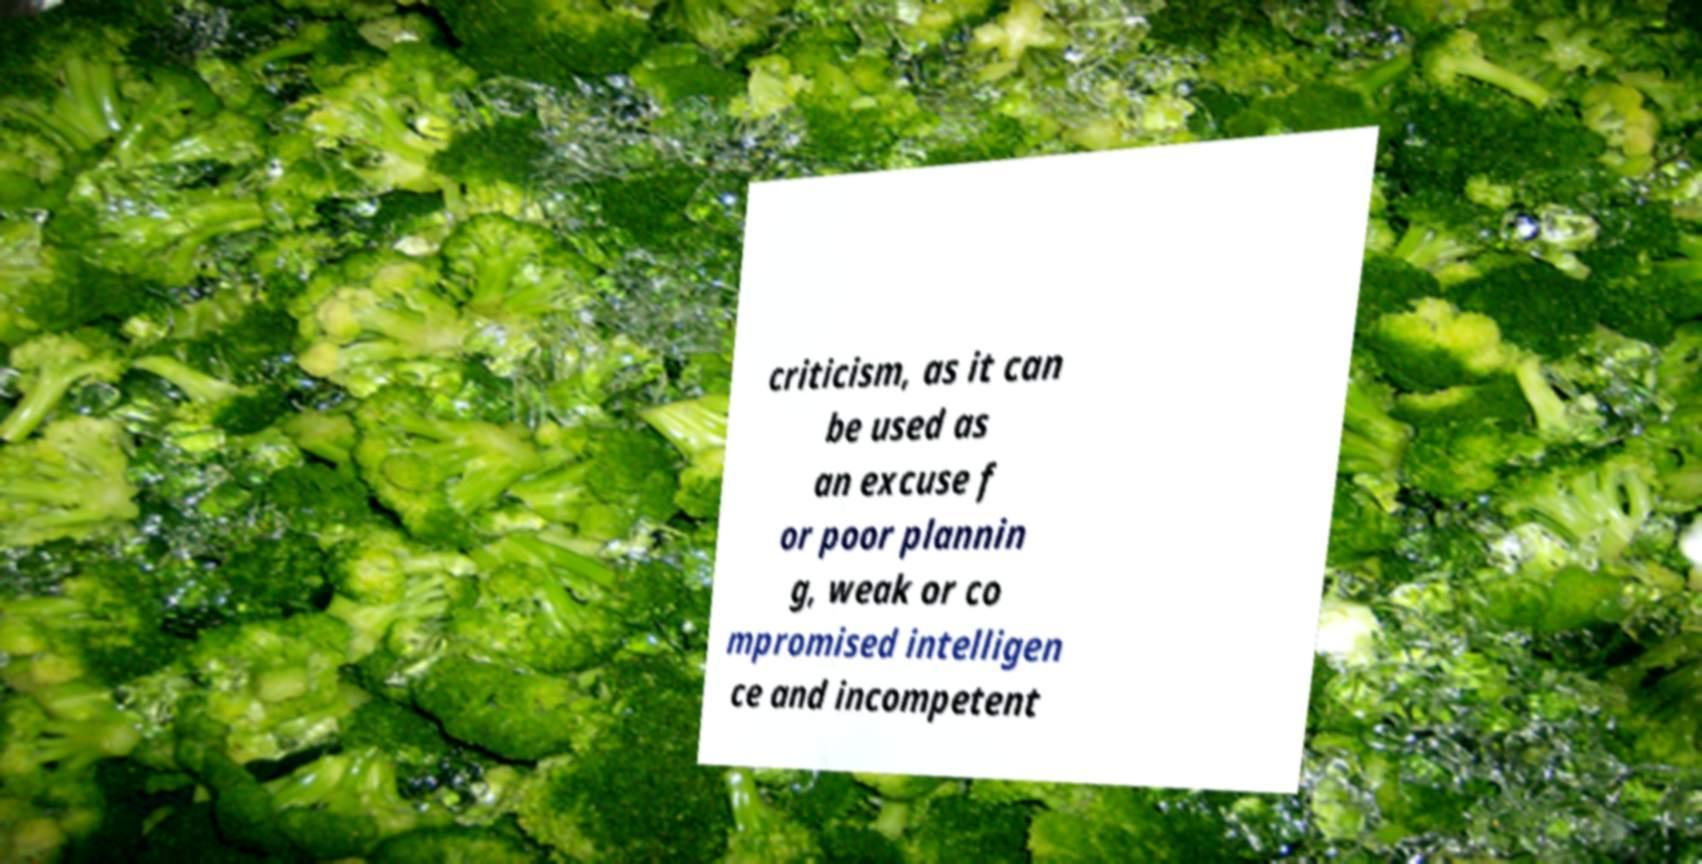Could you assist in decoding the text presented in this image and type it out clearly? criticism, as it can be used as an excuse f or poor plannin g, weak or co mpromised intelligen ce and incompetent 